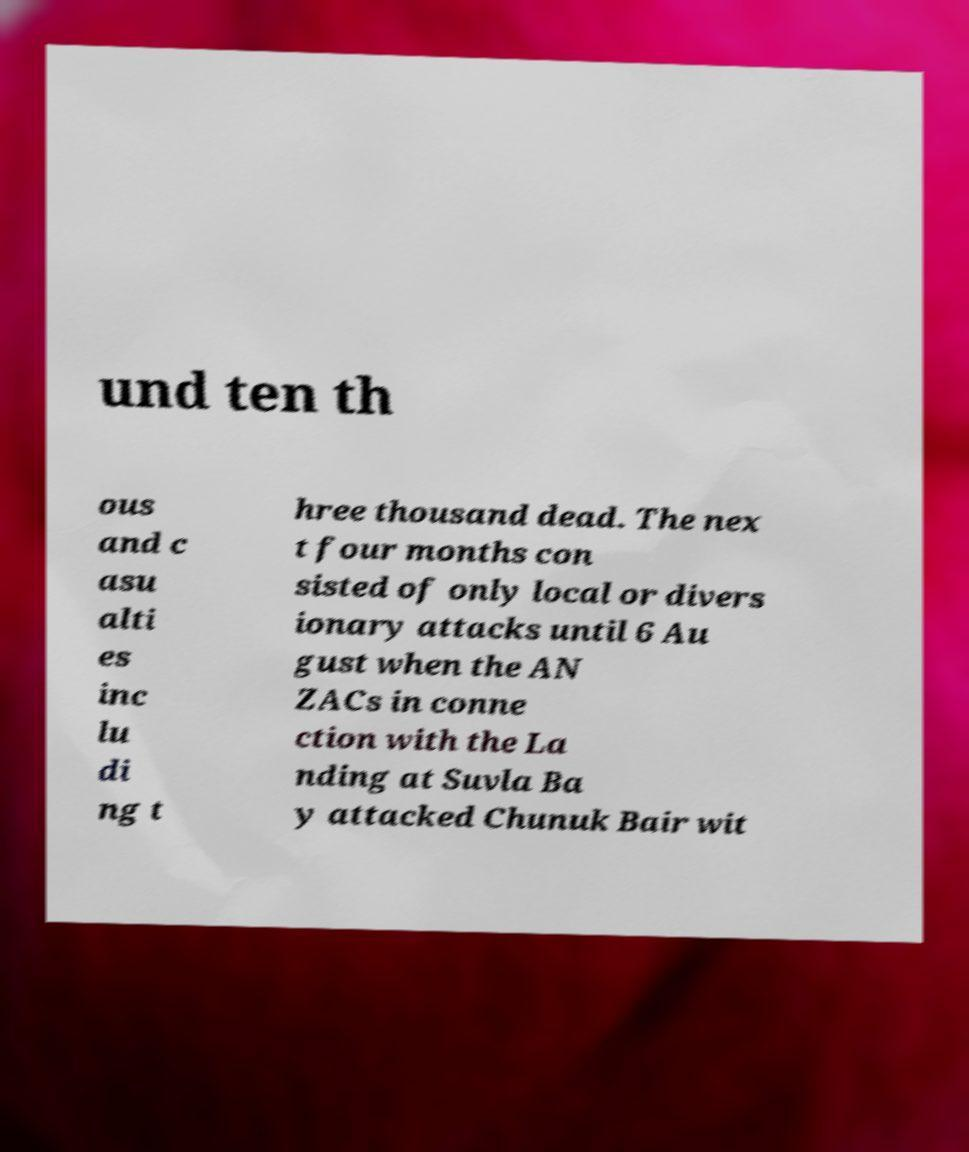Can you read and provide the text displayed in the image?This photo seems to have some interesting text. Can you extract and type it out for me? und ten th ous and c asu alti es inc lu di ng t hree thousand dead. The nex t four months con sisted of only local or divers ionary attacks until 6 Au gust when the AN ZACs in conne ction with the La nding at Suvla Ba y attacked Chunuk Bair wit 